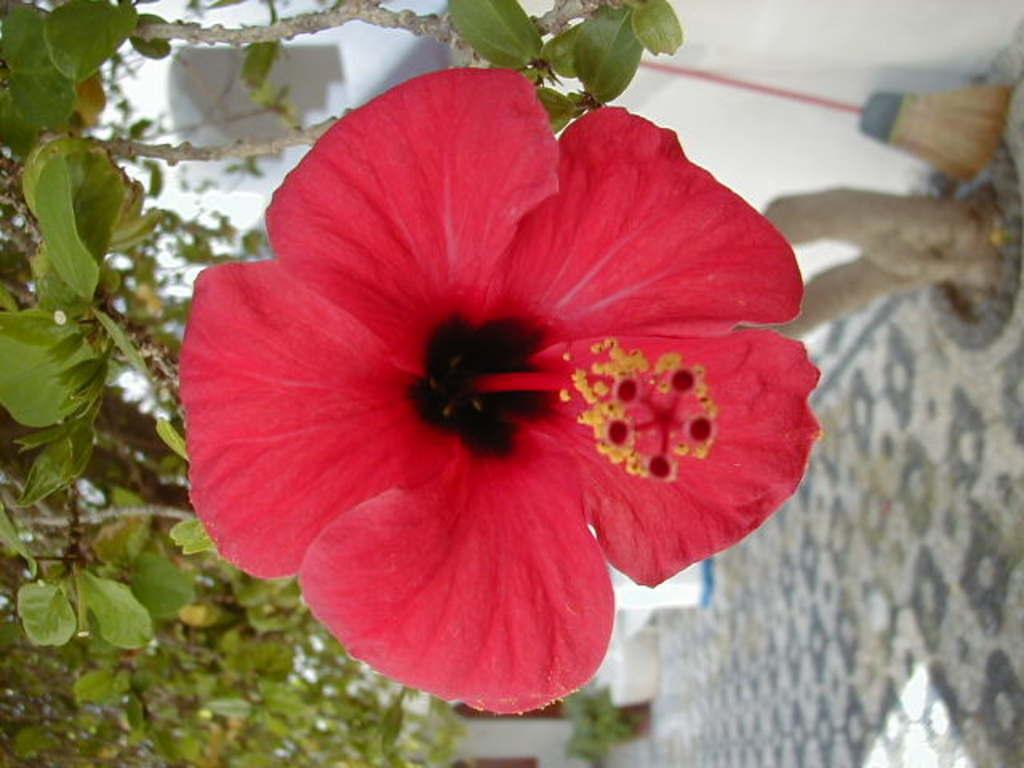What type of plant can be seen in the image? There is a plant in the image. Can you describe the main feature of the plant? There is a flower in the middle of the image. What object is located in front of the wall? There is a sweeping broom in front of the wall. What type of song can be heard coming from the frogs in the image? There are no frogs present in the image, so it's not possible to determine what, if any, song might be heard. 